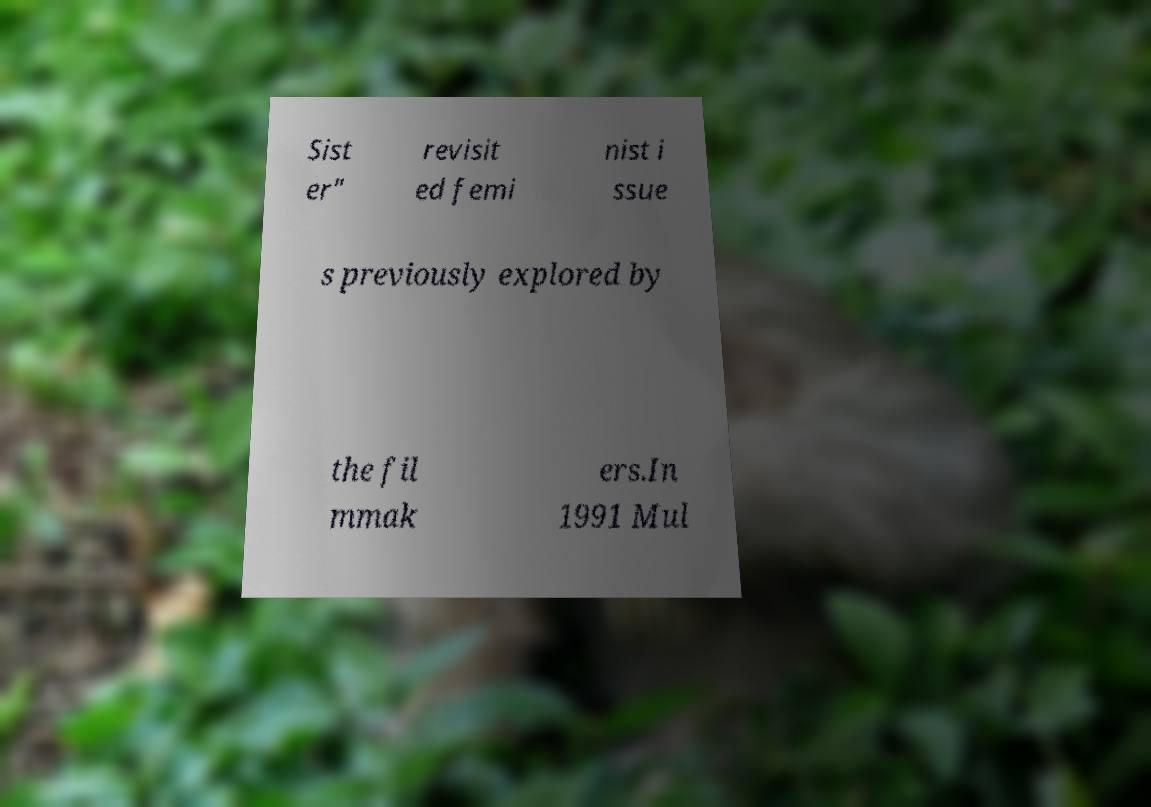Please read and relay the text visible in this image. What does it say? Sist er" revisit ed femi nist i ssue s previously explored by the fil mmak ers.In 1991 Mul 